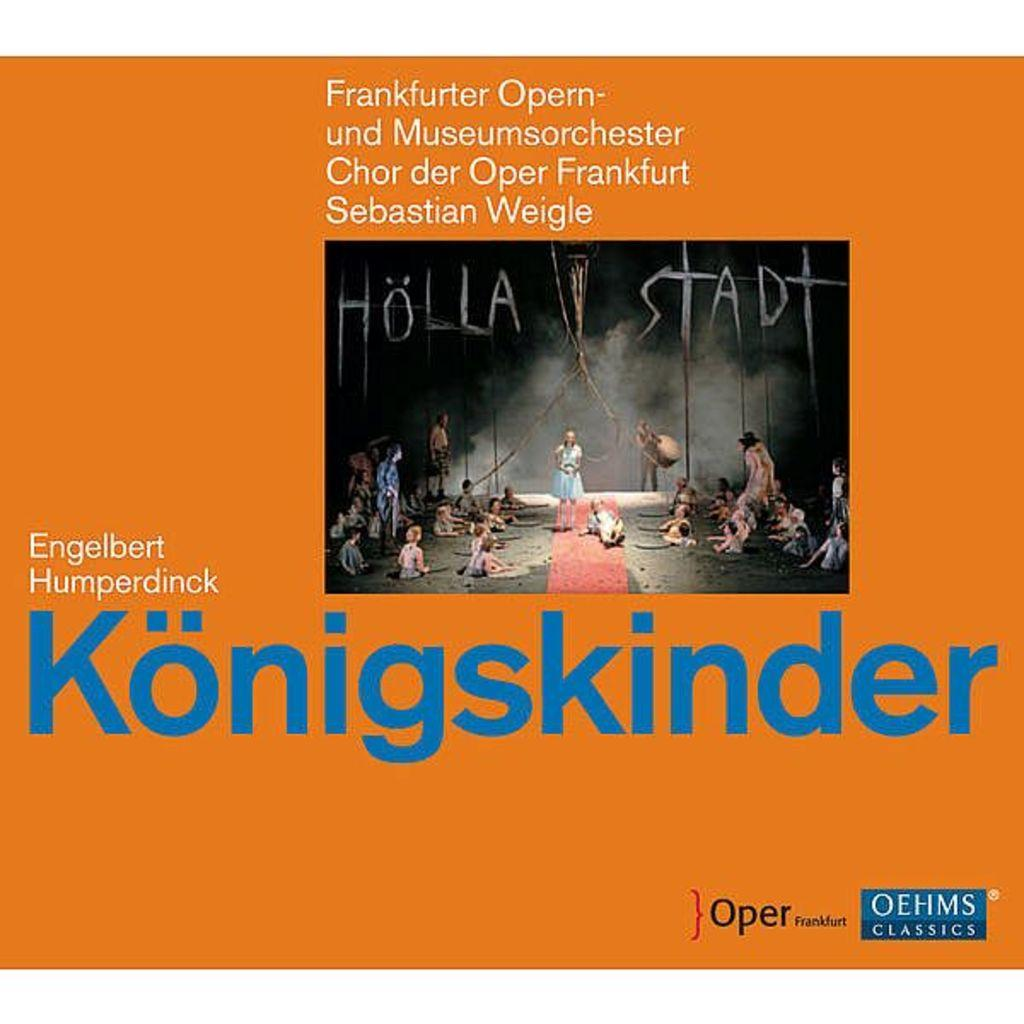<image>
Summarize the visual content of the image. OEHMS Classics and Oper frankfurt logo on a Konigskinder poster. 